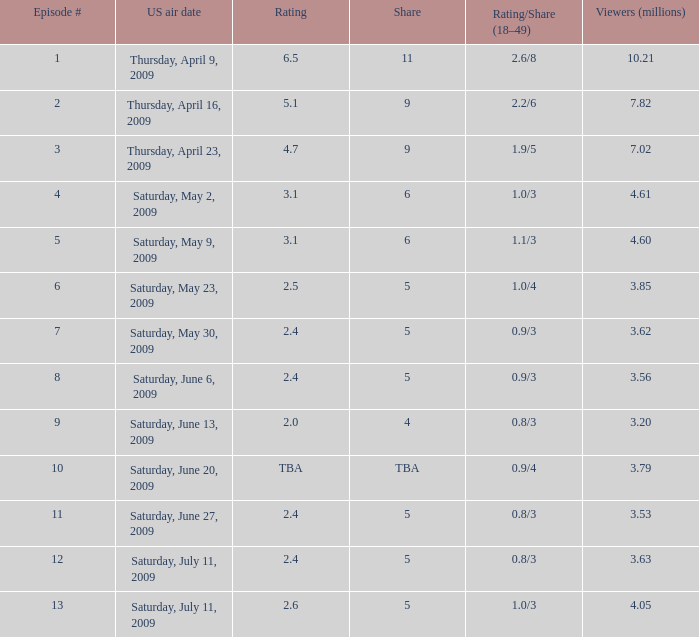What is the lowest number of million viewers for an episode before episode 5 with a rating/share of 1.1/3? None. 